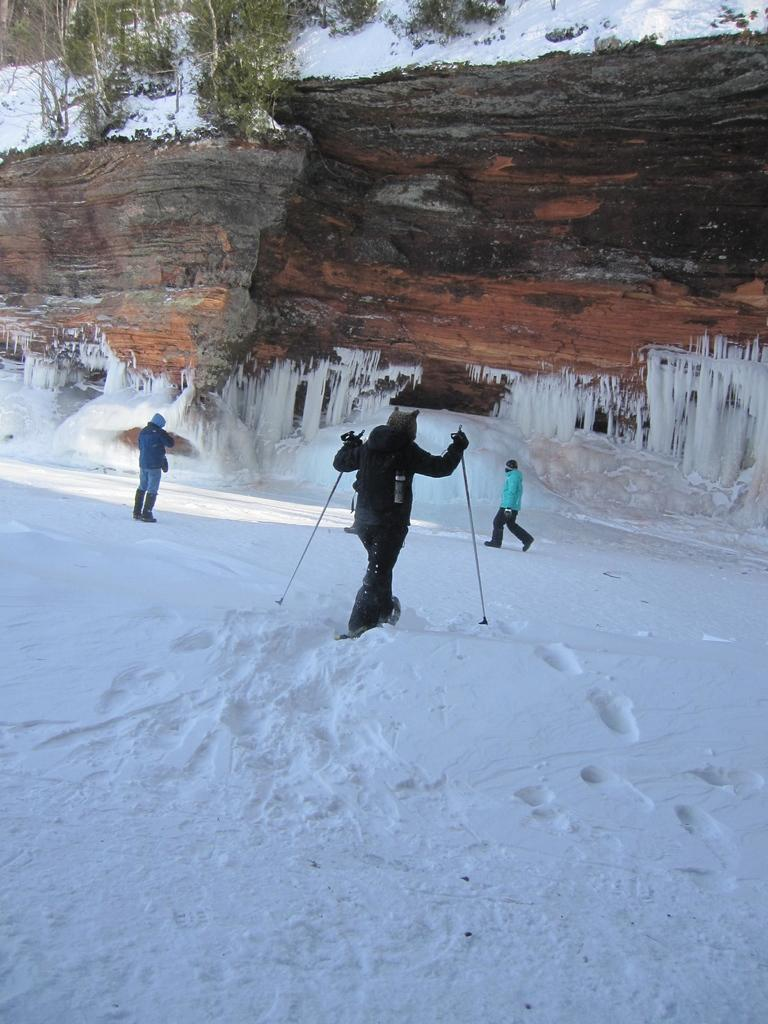What is the person in the image doing? There is a person skiing in the image. On what surface is the person skiing? The person is skiing on snow. What can be seen in the background of the image? There are people, a hill, and trees in the background of the image. What is the person thinking about while skiing in the image? The image does not provide information about the person's thoughts, so we cannot determine what they might be thinking. 